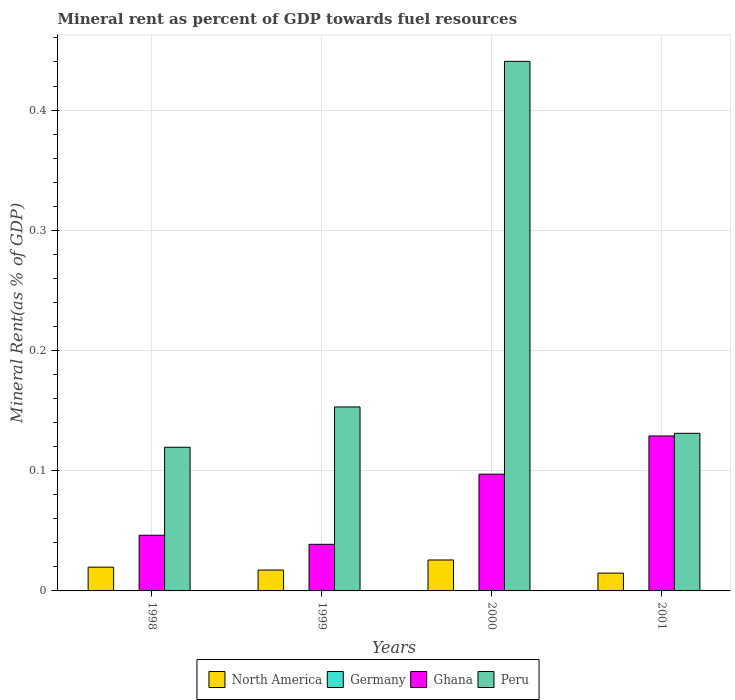How many different coloured bars are there?
Give a very brief answer. 4. Are the number of bars per tick equal to the number of legend labels?
Your answer should be compact. Yes. Are the number of bars on each tick of the X-axis equal?
Give a very brief answer. Yes. How many bars are there on the 3rd tick from the left?
Provide a succinct answer. 4. What is the mineral rent in North America in 1999?
Your response must be concise. 0.02. Across all years, what is the maximum mineral rent in North America?
Offer a very short reply. 0.03. Across all years, what is the minimum mineral rent in North America?
Your answer should be compact. 0.01. In which year was the mineral rent in Ghana minimum?
Provide a succinct answer. 1999. What is the total mineral rent in Ghana in the graph?
Your answer should be compact. 0.31. What is the difference between the mineral rent in Peru in 1998 and that in 2001?
Keep it short and to the point. -0.01. What is the difference between the mineral rent in Peru in 2000 and the mineral rent in Ghana in 1998?
Make the answer very short. 0.39. What is the average mineral rent in North America per year?
Make the answer very short. 0.02. In the year 1999, what is the difference between the mineral rent in North America and mineral rent in Peru?
Offer a terse response. -0.14. In how many years, is the mineral rent in North America greater than 0.42000000000000004 %?
Provide a short and direct response. 0. What is the ratio of the mineral rent in Germany in 1999 to that in 2001?
Your answer should be very brief. 0.7. Is the mineral rent in North America in 1998 less than that in 2001?
Provide a short and direct response. No. What is the difference between the highest and the second highest mineral rent in Peru?
Offer a very short reply. 0.29. What is the difference between the highest and the lowest mineral rent in Germany?
Your answer should be compact. 6.31008199647012e-5. In how many years, is the mineral rent in Peru greater than the average mineral rent in Peru taken over all years?
Make the answer very short. 1. What does the 4th bar from the left in 1998 represents?
Provide a succinct answer. Peru. Is it the case that in every year, the sum of the mineral rent in Ghana and mineral rent in Peru is greater than the mineral rent in Germany?
Your answer should be very brief. Yes. How many bars are there?
Offer a very short reply. 16. Does the graph contain grids?
Your answer should be compact. Yes. Where does the legend appear in the graph?
Provide a succinct answer. Bottom center. How many legend labels are there?
Your response must be concise. 4. How are the legend labels stacked?
Your response must be concise. Horizontal. What is the title of the graph?
Your response must be concise. Mineral rent as percent of GDP towards fuel resources. What is the label or title of the X-axis?
Give a very brief answer. Years. What is the label or title of the Y-axis?
Provide a succinct answer. Mineral Rent(as % of GDP). What is the Mineral Rent(as % of GDP) in North America in 1998?
Give a very brief answer. 0.02. What is the Mineral Rent(as % of GDP) in Germany in 1998?
Offer a very short reply. 5.28914312966038e-5. What is the Mineral Rent(as % of GDP) in Ghana in 1998?
Provide a succinct answer. 0.05. What is the Mineral Rent(as % of GDP) in Peru in 1998?
Give a very brief answer. 0.12. What is the Mineral Rent(as % of GDP) in North America in 1999?
Provide a short and direct response. 0.02. What is the Mineral Rent(as % of GDP) of Germany in 1999?
Give a very brief answer. 7.59471027883187e-5. What is the Mineral Rent(as % of GDP) in Ghana in 1999?
Your answer should be very brief. 0.04. What is the Mineral Rent(as % of GDP) in Peru in 1999?
Give a very brief answer. 0.15. What is the Mineral Rent(as % of GDP) of North America in 2000?
Your answer should be very brief. 0.03. What is the Mineral Rent(as % of GDP) of Germany in 2000?
Ensure brevity in your answer.  0. What is the Mineral Rent(as % of GDP) of Ghana in 2000?
Your response must be concise. 0.1. What is the Mineral Rent(as % of GDP) of Peru in 2000?
Give a very brief answer. 0.44. What is the Mineral Rent(as % of GDP) in North America in 2001?
Give a very brief answer. 0.01. What is the Mineral Rent(as % of GDP) of Germany in 2001?
Make the answer very short. 0. What is the Mineral Rent(as % of GDP) of Ghana in 2001?
Provide a succinct answer. 0.13. What is the Mineral Rent(as % of GDP) of Peru in 2001?
Ensure brevity in your answer.  0.13. Across all years, what is the maximum Mineral Rent(as % of GDP) in North America?
Make the answer very short. 0.03. Across all years, what is the maximum Mineral Rent(as % of GDP) of Germany?
Offer a very short reply. 0. Across all years, what is the maximum Mineral Rent(as % of GDP) in Ghana?
Offer a terse response. 0.13. Across all years, what is the maximum Mineral Rent(as % of GDP) in Peru?
Ensure brevity in your answer.  0.44. Across all years, what is the minimum Mineral Rent(as % of GDP) in North America?
Give a very brief answer. 0.01. Across all years, what is the minimum Mineral Rent(as % of GDP) in Germany?
Offer a very short reply. 5.28914312966038e-5. Across all years, what is the minimum Mineral Rent(as % of GDP) in Ghana?
Your answer should be compact. 0.04. Across all years, what is the minimum Mineral Rent(as % of GDP) of Peru?
Offer a terse response. 0.12. What is the total Mineral Rent(as % of GDP) of North America in the graph?
Provide a succinct answer. 0.08. What is the total Mineral Rent(as % of GDP) in Ghana in the graph?
Provide a succinct answer. 0.31. What is the total Mineral Rent(as % of GDP) of Peru in the graph?
Your answer should be very brief. 0.84. What is the difference between the Mineral Rent(as % of GDP) in North America in 1998 and that in 1999?
Provide a succinct answer. 0. What is the difference between the Mineral Rent(as % of GDP) in Germany in 1998 and that in 1999?
Provide a short and direct response. -0. What is the difference between the Mineral Rent(as % of GDP) in Ghana in 1998 and that in 1999?
Your answer should be very brief. 0.01. What is the difference between the Mineral Rent(as % of GDP) of Peru in 1998 and that in 1999?
Make the answer very short. -0.03. What is the difference between the Mineral Rent(as % of GDP) of North America in 1998 and that in 2000?
Your response must be concise. -0.01. What is the difference between the Mineral Rent(as % of GDP) of Germany in 1998 and that in 2000?
Your response must be concise. -0. What is the difference between the Mineral Rent(as % of GDP) of Ghana in 1998 and that in 2000?
Provide a short and direct response. -0.05. What is the difference between the Mineral Rent(as % of GDP) of Peru in 1998 and that in 2000?
Ensure brevity in your answer.  -0.32. What is the difference between the Mineral Rent(as % of GDP) of North America in 1998 and that in 2001?
Your answer should be very brief. 0.01. What is the difference between the Mineral Rent(as % of GDP) in Germany in 1998 and that in 2001?
Your answer should be very brief. -0. What is the difference between the Mineral Rent(as % of GDP) in Ghana in 1998 and that in 2001?
Give a very brief answer. -0.08. What is the difference between the Mineral Rent(as % of GDP) in Peru in 1998 and that in 2001?
Provide a short and direct response. -0.01. What is the difference between the Mineral Rent(as % of GDP) in North America in 1999 and that in 2000?
Make the answer very short. -0.01. What is the difference between the Mineral Rent(as % of GDP) in Germany in 1999 and that in 2000?
Make the answer very short. -0. What is the difference between the Mineral Rent(as % of GDP) in Ghana in 1999 and that in 2000?
Your answer should be compact. -0.06. What is the difference between the Mineral Rent(as % of GDP) in Peru in 1999 and that in 2000?
Provide a short and direct response. -0.29. What is the difference between the Mineral Rent(as % of GDP) of North America in 1999 and that in 2001?
Provide a succinct answer. 0. What is the difference between the Mineral Rent(as % of GDP) in Ghana in 1999 and that in 2001?
Keep it short and to the point. -0.09. What is the difference between the Mineral Rent(as % of GDP) of Peru in 1999 and that in 2001?
Ensure brevity in your answer.  0.02. What is the difference between the Mineral Rent(as % of GDP) in North America in 2000 and that in 2001?
Offer a terse response. 0.01. What is the difference between the Mineral Rent(as % of GDP) in Germany in 2000 and that in 2001?
Provide a succinct answer. 0. What is the difference between the Mineral Rent(as % of GDP) in Ghana in 2000 and that in 2001?
Your answer should be compact. -0.03. What is the difference between the Mineral Rent(as % of GDP) in Peru in 2000 and that in 2001?
Make the answer very short. 0.31. What is the difference between the Mineral Rent(as % of GDP) in North America in 1998 and the Mineral Rent(as % of GDP) in Germany in 1999?
Your answer should be very brief. 0.02. What is the difference between the Mineral Rent(as % of GDP) of North America in 1998 and the Mineral Rent(as % of GDP) of Ghana in 1999?
Your answer should be very brief. -0.02. What is the difference between the Mineral Rent(as % of GDP) of North America in 1998 and the Mineral Rent(as % of GDP) of Peru in 1999?
Offer a terse response. -0.13. What is the difference between the Mineral Rent(as % of GDP) in Germany in 1998 and the Mineral Rent(as % of GDP) in Ghana in 1999?
Provide a short and direct response. -0.04. What is the difference between the Mineral Rent(as % of GDP) in Germany in 1998 and the Mineral Rent(as % of GDP) in Peru in 1999?
Provide a succinct answer. -0.15. What is the difference between the Mineral Rent(as % of GDP) of Ghana in 1998 and the Mineral Rent(as % of GDP) of Peru in 1999?
Give a very brief answer. -0.11. What is the difference between the Mineral Rent(as % of GDP) of North America in 1998 and the Mineral Rent(as % of GDP) of Germany in 2000?
Keep it short and to the point. 0.02. What is the difference between the Mineral Rent(as % of GDP) in North America in 1998 and the Mineral Rent(as % of GDP) in Ghana in 2000?
Give a very brief answer. -0.08. What is the difference between the Mineral Rent(as % of GDP) of North America in 1998 and the Mineral Rent(as % of GDP) of Peru in 2000?
Keep it short and to the point. -0.42. What is the difference between the Mineral Rent(as % of GDP) of Germany in 1998 and the Mineral Rent(as % of GDP) of Ghana in 2000?
Your answer should be compact. -0.1. What is the difference between the Mineral Rent(as % of GDP) in Germany in 1998 and the Mineral Rent(as % of GDP) in Peru in 2000?
Offer a very short reply. -0.44. What is the difference between the Mineral Rent(as % of GDP) of Ghana in 1998 and the Mineral Rent(as % of GDP) of Peru in 2000?
Make the answer very short. -0.39. What is the difference between the Mineral Rent(as % of GDP) in North America in 1998 and the Mineral Rent(as % of GDP) in Germany in 2001?
Offer a very short reply. 0.02. What is the difference between the Mineral Rent(as % of GDP) in North America in 1998 and the Mineral Rent(as % of GDP) in Ghana in 2001?
Give a very brief answer. -0.11. What is the difference between the Mineral Rent(as % of GDP) in North America in 1998 and the Mineral Rent(as % of GDP) in Peru in 2001?
Make the answer very short. -0.11. What is the difference between the Mineral Rent(as % of GDP) of Germany in 1998 and the Mineral Rent(as % of GDP) of Ghana in 2001?
Offer a very short reply. -0.13. What is the difference between the Mineral Rent(as % of GDP) in Germany in 1998 and the Mineral Rent(as % of GDP) in Peru in 2001?
Your response must be concise. -0.13. What is the difference between the Mineral Rent(as % of GDP) in Ghana in 1998 and the Mineral Rent(as % of GDP) in Peru in 2001?
Provide a short and direct response. -0.08. What is the difference between the Mineral Rent(as % of GDP) in North America in 1999 and the Mineral Rent(as % of GDP) in Germany in 2000?
Your answer should be compact. 0.02. What is the difference between the Mineral Rent(as % of GDP) of North America in 1999 and the Mineral Rent(as % of GDP) of Ghana in 2000?
Make the answer very short. -0.08. What is the difference between the Mineral Rent(as % of GDP) of North America in 1999 and the Mineral Rent(as % of GDP) of Peru in 2000?
Make the answer very short. -0.42. What is the difference between the Mineral Rent(as % of GDP) in Germany in 1999 and the Mineral Rent(as % of GDP) in Ghana in 2000?
Give a very brief answer. -0.1. What is the difference between the Mineral Rent(as % of GDP) of Germany in 1999 and the Mineral Rent(as % of GDP) of Peru in 2000?
Make the answer very short. -0.44. What is the difference between the Mineral Rent(as % of GDP) of Ghana in 1999 and the Mineral Rent(as % of GDP) of Peru in 2000?
Ensure brevity in your answer.  -0.4. What is the difference between the Mineral Rent(as % of GDP) of North America in 1999 and the Mineral Rent(as % of GDP) of Germany in 2001?
Your answer should be very brief. 0.02. What is the difference between the Mineral Rent(as % of GDP) in North America in 1999 and the Mineral Rent(as % of GDP) in Ghana in 2001?
Make the answer very short. -0.11. What is the difference between the Mineral Rent(as % of GDP) in North America in 1999 and the Mineral Rent(as % of GDP) in Peru in 2001?
Keep it short and to the point. -0.11. What is the difference between the Mineral Rent(as % of GDP) of Germany in 1999 and the Mineral Rent(as % of GDP) of Ghana in 2001?
Offer a very short reply. -0.13. What is the difference between the Mineral Rent(as % of GDP) of Germany in 1999 and the Mineral Rent(as % of GDP) of Peru in 2001?
Offer a terse response. -0.13. What is the difference between the Mineral Rent(as % of GDP) of Ghana in 1999 and the Mineral Rent(as % of GDP) of Peru in 2001?
Give a very brief answer. -0.09. What is the difference between the Mineral Rent(as % of GDP) of North America in 2000 and the Mineral Rent(as % of GDP) of Germany in 2001?
Offer a very short reply. 0.03. What is the difference between the Mineral Rent(as % of GDP) of North America in 2000 and the Mineral Rent(as % of GDP) of Ghana in 2001?
Provide a short and direct response. -0.1. What is the difference between the Mineral Rent(as % of GDP) of North America in 2000 and the Mineral Rent(as % of GDP) of Peru in 2001?
Provide a short and direct response. -0.11. What is the difference between the Mineral Rent(as % of GDP) of Germany in 2000 and the Mineral Rent(as % of GDP) of Ghana in 2001?
Your answer should be compact. -0.13. What is the difference between the Mineral Rent(as % of GDP) in Germany in 2000 and the Mineral Rent(as % of GDP) in Peru in 2001?
Offer a very short reply. -0.13. What is the difference between the Mineral Rent(as % of GDP) of Ghana in 2000 and the Mineral Rent(as % of GDP) of Peru in 2001?
Provide a succinct answer. -0.03. What is the average Mineral Rent(as % of GDP) in North America per year?
Keep it short and to the point. 0.02. What is the average Mineral Rent(as % of GDP) in Ghana per year?
Your response must be concise. 0.08. What is the average Mineral Rent(as % of GDP) of Peru per year?
Keep it short and to the point. 0.21. In the year 1998, what is the difference between the Mineral Rent(as % of GDP) of North America and Mineral Rent(as % of GDP) of Germany?
Your answer should be very brief. 0.02. In the year 1998, what is the difference between the Mineral Rent(as % of GDP) of North America and Mineral Rent(as % of GDP) of Ghana?
Your answer should be compact. -0.03. In the year 1998, what is the difference between the Mineral Rent(as % of GDP) of North America and Mineral Rent(as % of GDP) of Peru?
Offer a very short reply. -0.1. In the year 1998, what is the difference between the Mineral Rent(as % of GDP) of Germany and Mineral Rent(as % of GDP) of Ghana?
Offer a terse response. -0.05. In the year 1998, what is the difference between the Mineral Rent(as % of GDP) of Germany and Mineral Rent(as % of GDP) of Peru?
Give a very brief answer. -0.12. In the year 1998, what is the difference between the Mineral Rent(as % of GDP) in Ghana and Mineral Rent(as % of GDP) in Peru?
Provide a succinct answer. -0.07. In the year 1999, what is the difference between the Mineral Rent(as % of GDP) of North America and Mineral Rent(as % of GDP) of Germany?
Provide a succinct answer. 0.02. In the year 1999, what is the difference between the Mineral Rent(as % of GDP) of North America and Mineral Rent(as % of GDP) of Ghana?
Offer a terse response. -0.02. In the year 1999, what is the difference between the Mineral Rent(as % of GDP) in North America and Mineral Rent(as % of GDP) in Peru?
Make the answer very short. -0.14. In the year 1999, what is the difference between the Mineral Rent(as % of GDP) of Germany and Mineral Rent(as % of GDP) of Ghana?
Provide a succinct answer. -0.04. In the year 1999, what is the difference between the Mineral Rent(as % of GDP) in Germany and Mineral Rent(as % of GDP) in Peru?
Offer a terse response. -0.15. In the year 1999, what is the difference between the Mineral Rent(as % of GDP) in Ghana and Mineral Rent(as % of GDP) in Peru?
Your response must be concise. -0.11. In the year 2000, what is the difference between the Mineral Rent(as % of GDP) of North America and Mineral Rent(as % of GDP) of Germany?
Keep it short and to the point. 0.03. In the year 2000, what is the difference between the Mineral Rent(as % of GDP) of North America and Mineral Rent(as % of GDP) of Ghana?
Provide a short and direct response. -0.07. In the year 2000, what is the difference between the Mineral Rent(as % of GDP) in North America and Mineral Rent(as % of GDP) in Peru?
Give a very brief answer. -0.41. In the year 2000, what is the difference between the Mineral Rent(as % of GDP) of Germany and Mineral Rent(as % of GDP) of Ghana?
Provide a short and direct response. -0.1. In the year 2000, what is the difference between the Mineral Rent(as % of GDP) in Germany and Mineral Rent(as % of GDP) in Peru?
Your answer should be compact. -0.44. In the year 2000, what is the difference between the Mineral Rent(as % of GDP) of Ghana and Mineral Rent(as % of GDP) of Peru?
Your answer should be very brief. -0.34. In the year 2001, what is the difference between the Mineral Rent(as % of GDP) of North America and Mineral Rent(as % of GDP) of Germany?
Ensure brevity in your answer.  0.01. In the year 2001, what is the difference between the Mineral Rent(as % of GDP) of North America and Mineral Rent(as % of GDP) of Ghana?
Keep it short and to the point. -0.11. In the year 2001, what is the difference between the Mineral Rent(as % of GDP) of North America and Mineral Rent(as % of GDP) of Peru?
Your answer should be very brief. -0.12. In the year 2001, what is the difference between the Mineral Rent(as % of GDP) in Germany and Mineral Rent(as % of GDP) in Ghana?
Offer a very short reply. -0.13. In the year 2001, what is the difference between the Mineral Rent(as % of GDP) in Germany and Mineral Rent(as % of GDP) in Peru?
Keep it short and to the point. -0.13. In the year 2001, what is the difference between the Mineral Rent(as % of GDP) in Ghana and Mineral Rent(as % of GDP) in Peru?
Your answer should be compact. -0. What is the ratio of the Mineral Rent(as % of GDP) in North America in 1998 to that in 1999?
Offer a terse response. 1.14. What is the ratio of the Mineral Rent(as % of GDP) of Germany in 1998 to that in 1999?
Your response must be concise. 0.7. What is the ratio of the Mineral Rent(as % of GDP) of Ghana in 1998 to that in 1999?
Your response must be concise. 1.19. What is the ratio of the Mineral Rent(as % of GDP) in Peru in 1998 to that in 1999?
Offer a very short reply. 0.78. What is the ratio of the Mineral Rent(as % of GDP) of North America in 1998 to that in 2000?
Your response must be concise. 0.77. What is the ratio of the Mineral Rent(as % of GDP) in Germany in 1998 to that in 2000?
Provide a short and direct response. 0.46. What is the ratio of the Mineral Rent(as % of GDP) of Ghana in 1998 to that in 2000?
Ensure brevity in your answer.  0.48. What is the ratio of the Mineral Rent(as % of GDP) of Peru in 1998 to that in 2000?
Ensure brevity in your answer.  0.27. What is the ratio of the Mineral Rent(as % of GDP) of North America in 1998 to that in 2001?
Provide a short and direct response. 1.34. What is the ratio of the Mineral Rent(as % of GDP) of Germany in 1998 to that in 2001?
Offer a very short reply. 0.49. What is the ratio of the Mineral Rent(as % of GDP) of Ghana in 1998 to that in 2001?
Your answer should be very brief. 0.36. What is the ratio of the Mineral Rent(as % of GDP) of Peru in 1998 to that in 2001?
Keep it short and to the point. 0.91. What is the ratio of the Mineral Rent(as % of GDP) of North America in 1999 to that in 2000?
Provide a short and direct response. 0.67. What is the ratio of the Mineral Rent(as % of GDP) in Germany in 1999 to that in 2000?
Your response must be concise. 0.65. What is the ratio of the Mineral Rent(as % of GDP) in Ghana in 1999 to that in 2000?
Give a very brief answer. 0.4. What is the ratio of the Mineral Rent(as % of GDP) in Peru in 1999 to that in 2000?
Offer a very short reply. 0.35. What is the ratio of the Mineral Rent(as % of GDP) of North America in 1999 to that in 2001?
Keep it short and to the point. 1.17. What is the ratio of the Mineral Rent(as % of GDP) of Germany in 1999 to that in 2001?
Provide a succinct answer. 0.7. What is the ratio of the Mineral Rent(as % of GDP) of Ghana in 1999 to that in 2001?
Ensure brevity in your answer.  0.3. What is the ratio of the Mineral Rent(as % of GDP) of Peru in 1999 to that in 2001?
Offer a terse response. 1.17. What is the ratio of the Mineral Rent(as % of GDP) in North America in 2000 to that in 2001?
Ensure brevity in your answer.  1.74. What is the ratio of the Mineral Rent(as % of GDP) of Germany in 2000 to that in 2001?
Your response must be concise. 1.07. What is the ratio of the Mineral Rent(as % of GDP) in Ghana in 2000 to that in 2001?
Offer a very short reply. 0.75. What is the ratio of the Mineral Rent(as % of GDP) of Peru in 2000 to that in 2001?
Provide a succinct answer. 3.36. What is the difference between the highest and the second highest Mineral Rent(as % of GDP) of North America?
Your response must be concise. 0.01. What is the difference between the highest and the second highest Mineral Rent(as % of GDP) of Ghana?
Your answer should be very brief. 0.03. What is the difference between the highest and the second highest Mineral Rent(as % of GDP) of Peru?
Offer a terse response. 0.29. What is the difference between the highest and the lowest Mineral Rent(as % of GDP) in North America?
Offer a terse response. 0.01. What is the difference between the highest and the lowest Mineral Rent(as % of GDP) of Ghana?
Offer a terse response. 0.09. What is the difference between the highest and the lowest Mineral Rent(as % of GDP) in Peru?
Your answer should be very brief. 0.32. 